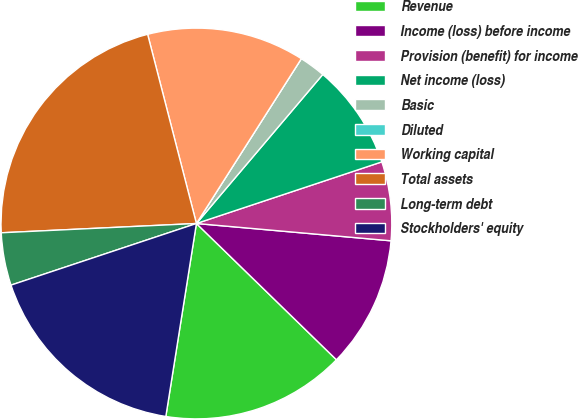<chart> <loc_0><loc_0><loc_500><loc_500><pie_chart><fcel>Revenue<fcel>Income (loss) before income<fcel>Provision (benefit) for income<fcel>Net income (loss)<fcel>Basic<fcel>Diluted<fcel>Working capital<fcel>Total assets<fcel>Long-term debt<fcel>Stockholders' equity<nl><fcel>15.22%<fcel>10.87%<fcel>6.52%<fcel>8.7%<fcel>2.17%<fcel>0.0%<fcel>13.04%<fcel>21.74%<fcel>4.35%<fcel>17.39%<nl></chart> 